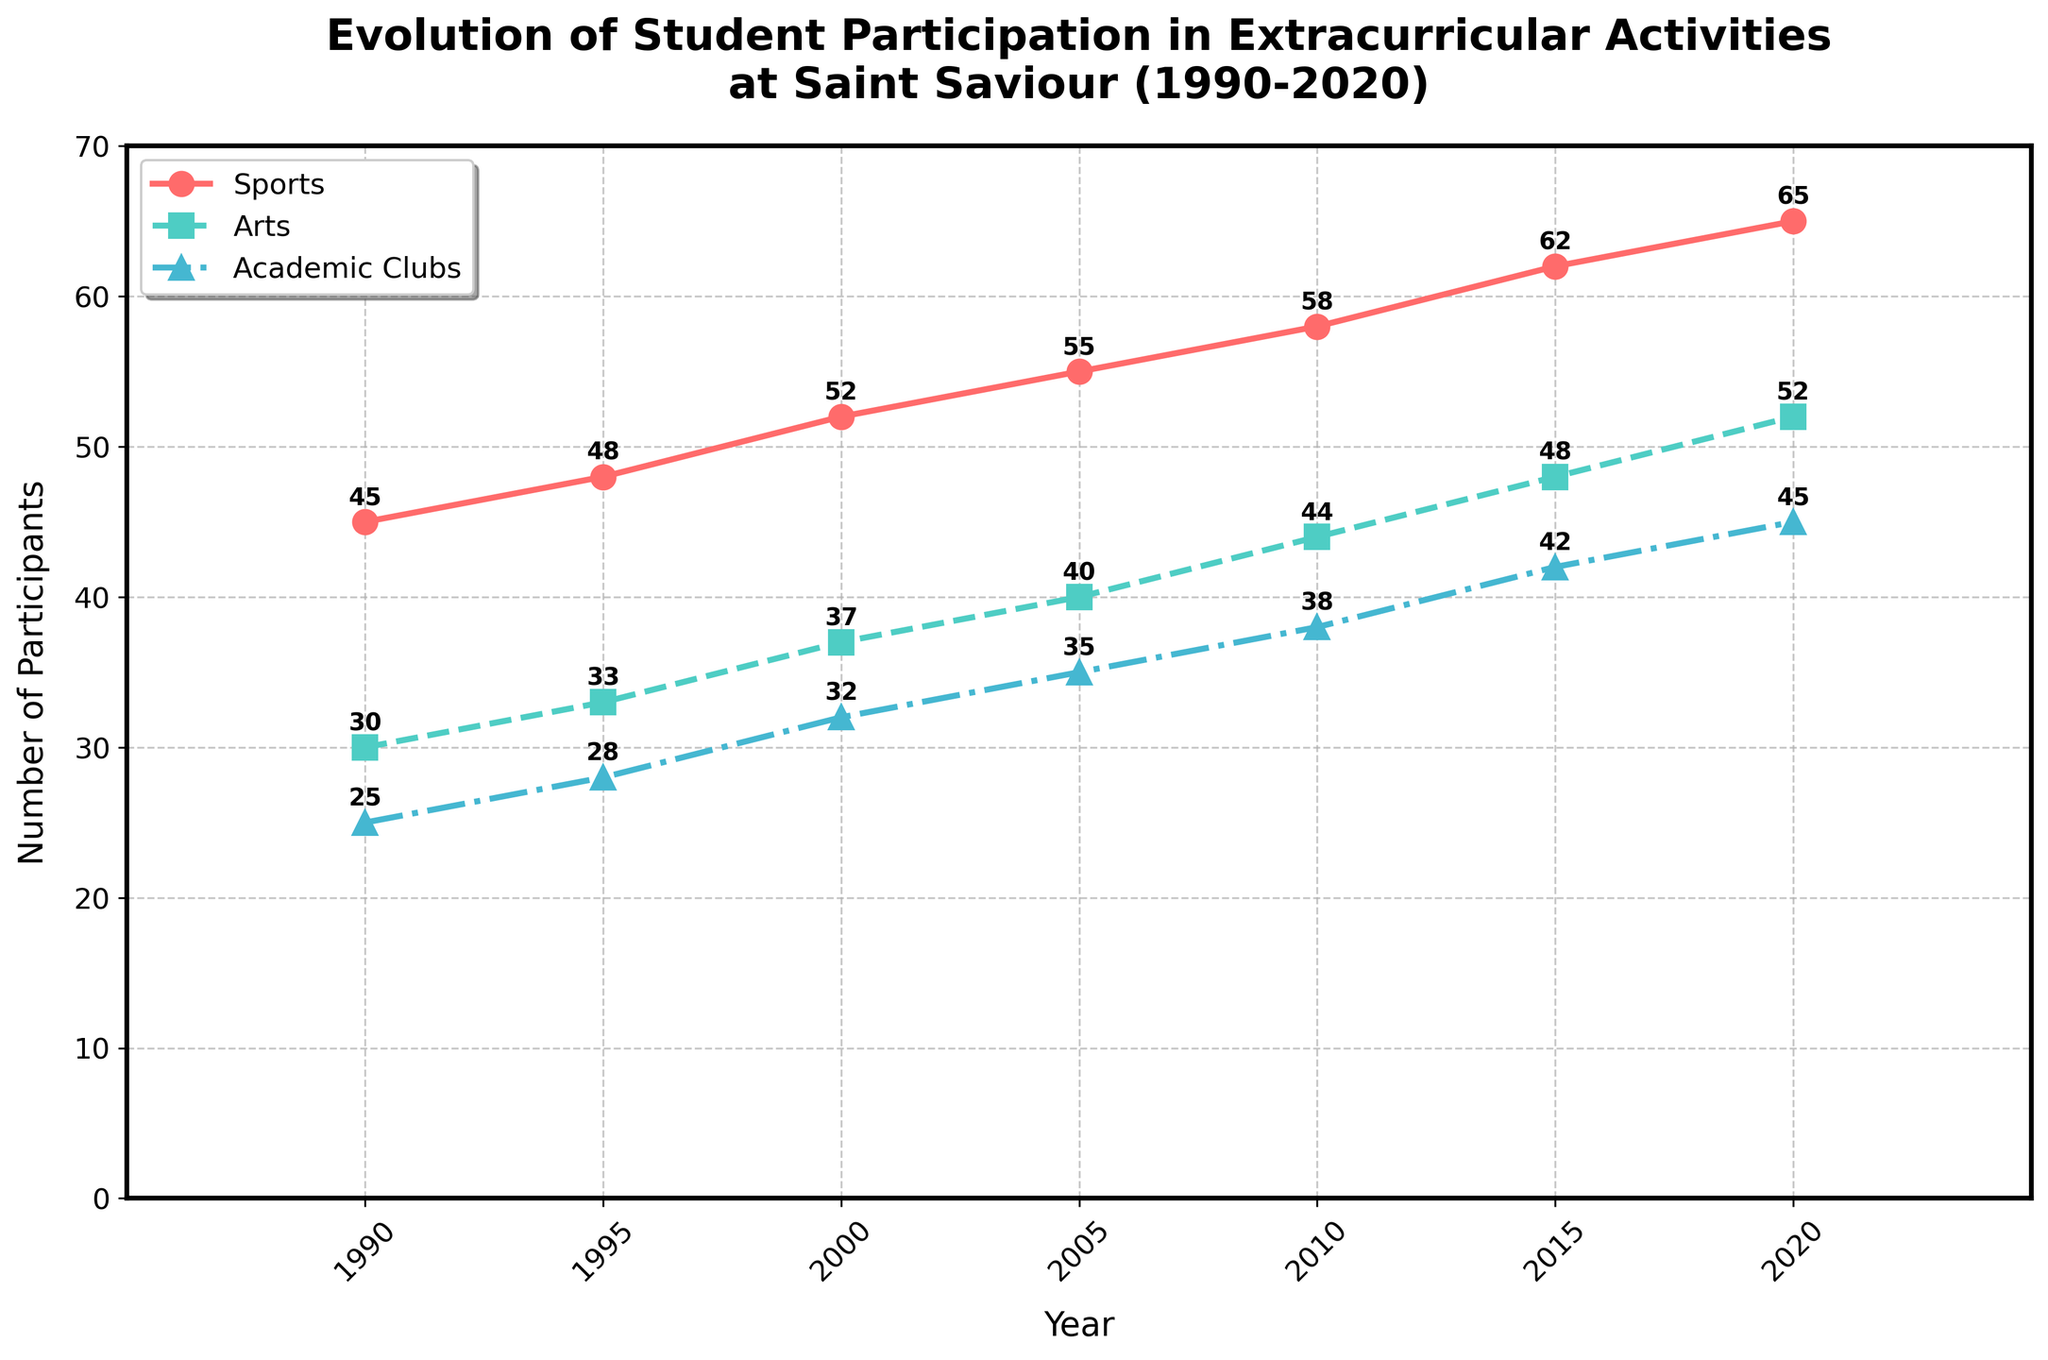Which type of extracurricular activity had the highest student participation in 2020? The figure shows the values for each type of activity in 2020; sports had 65, arts had 52, and academic clubs had 45. The highest value is 65 for sports.
Answer: Sports How much did student participation in academic clubs increase from 1990 to 2020? In 1990, participation in academic clubs was 25, and in 2020, it was 45. The increase is calculated by subtracting 25 from 45, which equals 20.
Answer: 20 In which year did participation in arts surpass 40? The figure shows that in 2005, participation in arts was 40, and in 2010, it was 44. Therefore, the first year arts surpassed 40 was 2010.
Answer: 2010 What is the average yearly participation in sports over the 30-year period? Add the yearly participation for sports and divide by the number of years. (45 + 48 + 52 + 55 + 58 + 62 + 65) / 7 = 385 / 7 ≈ 55
Answer: 55 Did the number of students participating in academic clubs ever surpass that of the arts during this period? Review the chart; at no point does the participation in academic clubs surpass that of the arts throughout the period from 1990 to 2020.
Answer: No 